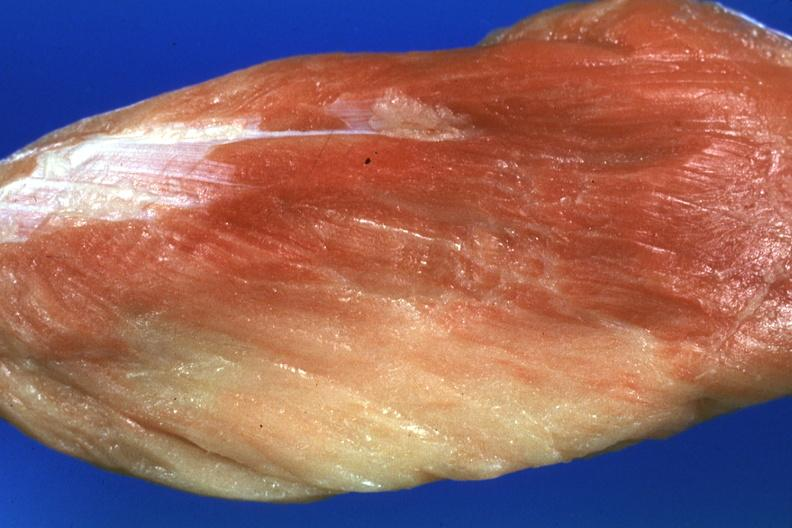what is present?
Answer the question using a single word or phrase. Soft tissue 